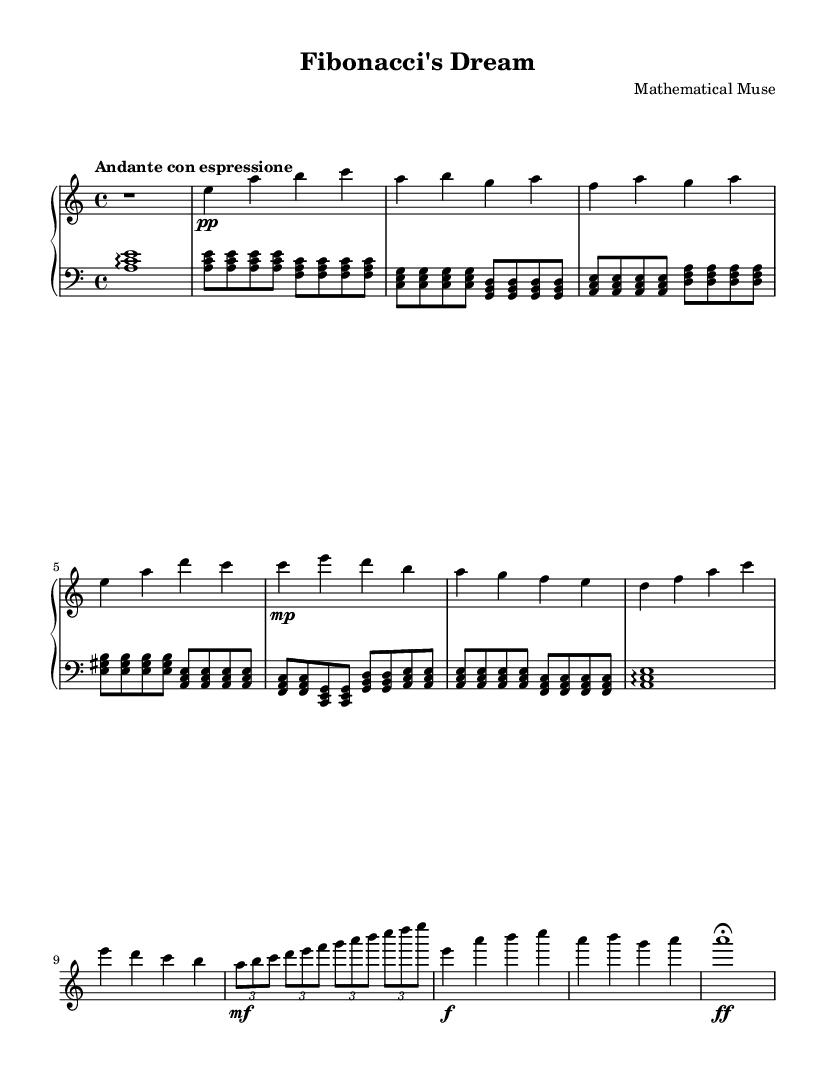What is the key signature of this music? The key signature is indicated by the number of sharps or flats in the piece. In this piece, there are no sharps or flats shown, so it must be A minor, which has no sharps or flats.
Answer: A minor What is the time signature of this music? The time signature is indicated by the numbers at the beginning of the piece. Here, it shows 4/4, meaning there are four beats in a measure and the quarter note gets one beat.
Answer: 4/4 What is the tempo marking for this piece? The tempo marking is shown in the score, indicating the speed of the piece. In this case, it says "Andante con espressione," which denotes a moderately slow tempo with expression.
Answer: Andante con espressione How many main themes are present in the piece? The piece has each section labeled distinctly, with Theme A and Theme B identified. Thus, there are two main themes present in the music.
Answer: 2 What is the dynamic marking at the beginning of Theme A? The dynamic marking at the beginning of Theme A indicates how softly the music should be played. It shows "pp," meaning pianississimo, which is very soft.
Answer: pp What does the term "fermata" indicate at the end of the piece? The term "fermata" indicates that the note or rest should be held longer than its usual duration, giving the performer the freedom to pause before concluding the piece.
Answer: Fermata 